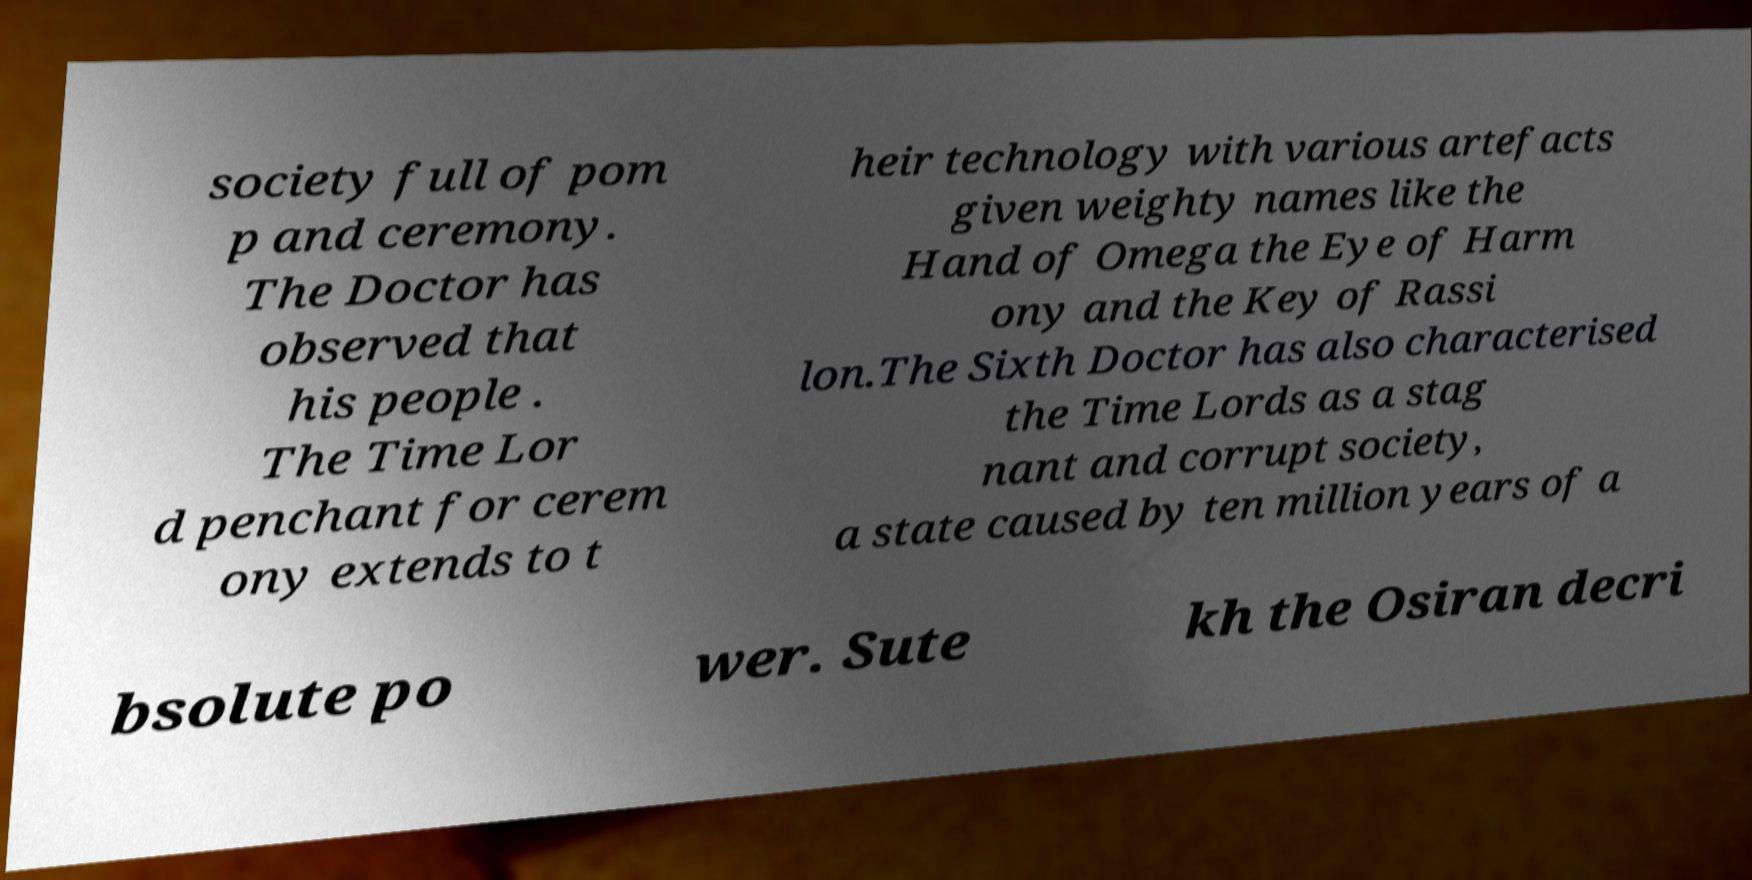For documentation purposes, I need the text within this image transcribed. Could you provide that? society full of pom p and ceremony. The Doctor has observed that his people . The Time Lor d penchant for cerem ony extends to t heir technology with various artefacts given weighty names like the Hand of Omega the Eye of Harm ony and the Key of Rassi lon.The Sixth Doctor has also characterised the Time Lords as a stag nant and corrupt society, a state caused by ten million years of a bsolute po wer. Sute kh the Osiran decri 